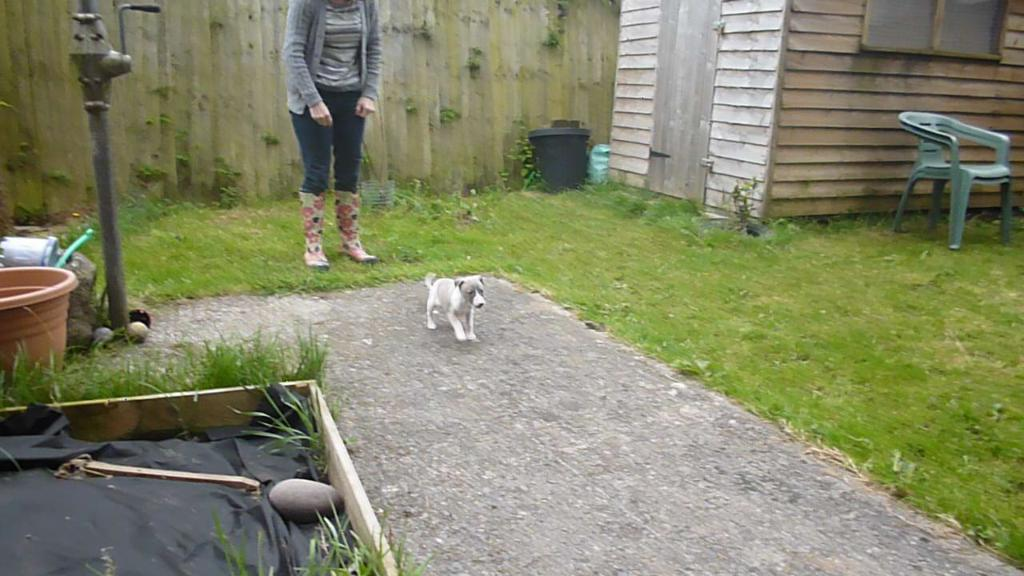Who or what is present in the image? There is a person and a small puppy in the image. Can you describe the puppy in the image? The puppy is small and is present in the image. What can be seen in the background of the image? There is a wooden ball and a wooden room in the background of the image. What decision does the person make in the image regarding the sail? There is no sail present in the image, and therefore no decision regarding a sail can be made. 